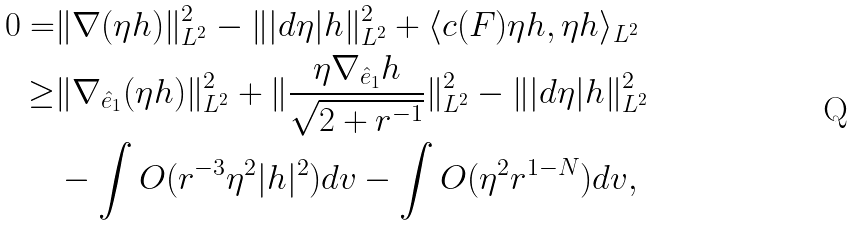<formula> <loc_0><loc_0><loc_500><loc_500>0 = & \| \nabla ( \eta h ) \| ^ { 2 } _ { L ^ { 2 } } - \| | d \eta | h \| ^ { 2 } _ { L ^ { 2 } } + \langle c ( F ) \eta h , \eta h \rangle _ { L ^ { 2 } } \\ \geq & \| \nabla _ { \hat { e } _ { 1 } } ( \eta h ) \| ^ { 2 } _ { L ^ { 2 } } + \| \frac { \eta \nabla _ { \hat { e } _ { 1 } } h } { \sqrt { 2 + r ^ { - 1 } } } \| ^ { 2 } _ { L ^ { 2 } } - \| | d \eta | h \| ^ { 2 } _ { L ^ { 2 } } \\ & - \int O ( r ^ { - 3 } \eta ^ { 2 } | h | ^ { 2 } ) d v - \int O ( \eta ^ { 2 } r ^ { 1 - N } ) d v ,</formula> 